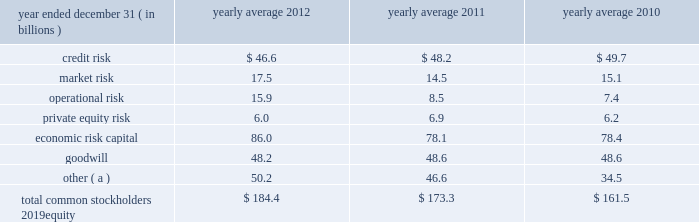Management 2019s discussion and analysis 120 jpmorgan chase & co./2012 annual report $ 12.0 billion , and jpmorgan clearing 2019s net capital was $ 6.6 billion , exceeding the minimum requirement by $ 5.0 billion .
In addition to its minimum net capital requirement , jpmorgan securities is required to hold tentative net capital in excess of $ 1.0 billion and is also required to notify the sec in the event that tentative net capital is less than $ 5.0 billion , in accordance with the market and credit risk standards of appendix e of the net capital rule .
As of december 31 , 2012 , jpmorgan securities had tentative net capital in excess of the minimum and notification requirements .
J.p .
Morgan securities plc ( formerly j.p .
Morgan securities ltd. ) is a wholly-owned subsidiary of jpmorgan chase bank , n.a .
And is the firm 2019s principal operating subsidiary in the u.k .
It has authority to engage in banking , investment banking and broker-dealer activities .
J.p .
Morgan securities plc is regulated by the u.k .
Financial services authority ( 201cfsa 201d ) .
At december 31 , 2012 , it had total capital of $ 20.8 billion , or a total capital ratio of 15.5% ( 15.5 % ) which exceeded the 8% ( 8 % ) well-capitalized standard applicable to it under basel 2.5 .
Economic risk capital jpmorgan chase assesses its capital adequacy relative to the risks underlying its business activities using internal risk-assessment methodologies .
The firm measures economic capital primarily based on four risk factors : credit , market , operational and private equity risk. .
( a ) reflects additional capital required , in the firm 2019s view , to meet its regulatory and debt rating objectives .
Credit risk capital credit risk capital is estimated separately for the wholesale businesses ( cib , cb and am ) and consumer business ( ccb ) .
Credit risk capital for the wholesale credit portfolio is defined in terms of unexpected credit losses , both from defaults and from declines in the value of the portfolio due to credit deterioration , measured over a one-year period at a confidence level consistent with an 201caa 201d credit rating standard .
Unexpected losses are losses in excess of those for which the allowance for credit losses is maintained .
The capital methodology is based on several principal drivers of credit risk : exposure at default ( or loan-equivalent amount ) , default likelihood , credit spreads , loss severity and portfolio correlation .
Credit risk capital for the consumer portfolio is based on product and other relevant risk segmentation .
Actual segment-level default and severity experience are used to estimate unexpected losses for a one-year horizon at a confidence level consistent with an 201caa 201d credit rating standard .
The decrease in credit risk capital in 2012 was driven by consumer portfolio runoff and continued model enhancements to better estimate future stress credit losses in the consumer portfolio .
See credit risk management on pages 134 2013135 of this annual report for more information about these credit risk measures .
Market risk capital the firm calculates market risk capital guided by the principle that capital should reflect the risk of loss in the value of the portfolios and financial instruments caused by adverse movements in market variables , such as interest and foreign exchange rates , credit spreads , and securities and commodities prices , taking into account the liquidity of the financial instruments .
Results from daily var , weekly stress tests , issuer credit spreads and default risk calculations , as well as other factors , are used to determine appropriate capital levels .
Market risk capital is allocated to each business segment based on its risk assessment .
The increase in market risk capital in 2012 was driven by increased risk in the synthetic credit portfolio .
See market risk management on pages 163 2013169 of this annual report for more information about these market risk measures .
Operational risk capital operational risk is the risk of loss resulting from inadequate or failed processes or systems , human factors or external events .
The operational risk capital model is based on actual losses and potential scenario-based losses , with adjustments to the capital calculation to reflect changes in the quality of the control environment .
The increase in operational risk capital in 2012 was primarily due to continued model enhancements to better capture large historical loss events , including mortgage-related litigation costs .
The increases that occurred during 2012 will be fully reflected in average operational risk capital in 2013 .
See operational risk management on pages 175 2013176 of this annual report for more information about operational risk .
Private equity risk capital capital is allocated to privately- and publicly-held securities , third-party fund investments , and commitments in the private equity portfolio , within the corporate/private equity segment , to cover the potential loss associated with a decline in equity markets and related asset devaluations .
In addition to negative market fluctuations , potential losses in private equity investment portfolios can be magnified by liquidity risk. .
How much more operational risk , in billions , did the firm take on in 2010 and 2011 combined than in 2012? 
Rationale: the total of operational risk of 2010 ( 7.4 ) and 2011 ( 8.5 ) equals 15.9 , the same number in billions of operational risk in 2012 ( 15.9 )
Computations: ((8.5 + 7.4) - (8.5 + 7.4))
Answer: 0.0. Management 2019s discussion and analysis 120 jpmorgan chase & co./2012 annual report $ 12.0 billion , and jpmorgan clearing 2019s net capital was $ 6.6 billion , exceeding the minimum requirement by $ 5.0 billion .
In addition to its minimum net capital requirement , jpmorgan securities is required to hold tentative net capital in excess of $ 1.0 billion and is also required to notify the sec in the event that tentative net capital is less than $ 5.0 billion , in accordance with the market and credit risk standards of appendix e of the net capital rule .
As of december 31 , 2012 , jpmorgan securities had tentative net capital in excess of the minimum and notification requirements .
J.p .
Morgan securities plc ( formerly j.p .
Morgan securities ltd. ) is a wholly-owned subsidiary of jpmorgan chase bank , n.a .
And is the firm 2019s principal operating subsidiary in the u.k .
It has authority to engage in banking , investment banking and broker-dealer activities .
J.p .
Morgan securities plc is regulated by the u.k .
Financial services authority ( 201cfsa 201d ) .
At december 31 , 2012 , it had total capital of $ 20.8 billion , or a total capital ratio of 15.5% ( 15.5 % ) which exceeded the 8% ( 8 % ) well-capitalized standard applicable to it under basel 2.5 .
Economic risk capital jpmorgan chase assesses its capital adequacy relative to the risks underlying its business activities using internal risk-assessment methodologies .
The firm measures economic capital primarily based on four risk factors : credit , market , operational and private equity risk. .
( a ) reflects additional capital required , in the firm 2019s view , to meet its regulatory and debt rating objectives .
Credit risk capital credit risk capital is estimated separately for the wholesale businesses ( cib , cb and am ) and consumer business ( ccb ) .
Credit risk capital for the wholesale credit portfolio is defined in terms of unexpected credit losses , both from defaults and from declines in the value of the portfolio due to credit deterioration , measured over a one-year period at a confidence level consistent with an 201caa 201d credit rating standard .
Unexpected losses are losses in excess of those for which the allowance for credit losses is maintained .
The capital methodology is based on several principal drivers of credit risk : exposure at default ( or loan-equivalent amount ) , default likelihood , credit spreads , loss severity and portfolio correlation .
Credit risk capital for the consumer portfolio is based on product and other relevant risk segmentation .
Actual segment-level default and severity experience are used to estimate unexpected losses for a one-year horizon at a confidence level consistent with an 201caa 201d credit rating standard .
The decrease in credit risk capital in 2012 was driven by consumer portfolio runoff and continued model enhancements to better estimate future stress credit losses in the consumer portfolio .
See credit risk management on pages 134 2013135 of this annual report for more information about these credit risk measures .
Market risk capital the firm calculates market risk capital guided by the principle that capital should reflect the risk of loss in the value of the portfolios and financial instruments caused by adverse movements in market variables , such as interest and foreign exchange rates , credit spreads , and securities and commodities prices , taking into account the liquidity of the financial instruments .
Results from daily var , weekly stress tests , issuer credit spreads and default risk calculations , as well as other factors , are used to determine appropriate capital levels .
Market risk capital is allocated to each business segment based on its risk assessment .
The increase in market risk capital in 2012 was driven by increased risk in the synthetic credit portfolio .
See market risk management on pages 163 2013169 of this annual report for more information about these market risk measures .
Operational risk capital operational risk is the risk of loss resulting from inadequate or failed processes or systems , human factors or external events .
The operational risk capital model is based on actual losses and potential scenario-based losses , with adjustments to the capital calculation to reflect changes in the quality of the control environment .
The increase in operational risk capital in 2012 was primarily due to continued model enhancements to better capture large historical loss events , including mortgage-related litigation costs .
The increases that occurred during 2012 will be fully reflected in average operational risk capital in 2013 .
See operational risk management on pages 175 2013176 of this annual report for more information about operational risk .
Private equity risk capital capital is allocated to privately- and publicly-held securities , third-party fund investments , and commitments in the private equity portfolio , within the corporate/private equity segment , to cover the potential loss associated with a decline in equity markets and related asset devaluations .
In addition to negative market fluctuations , potential losses in private equity investment portfolios can be magnified by liquidity risk. .
In 2012 what was the ratio of the 3 credit risk to the market risk? 
Computations: (46.6 / 17.5)
Answer: 2.66286. 